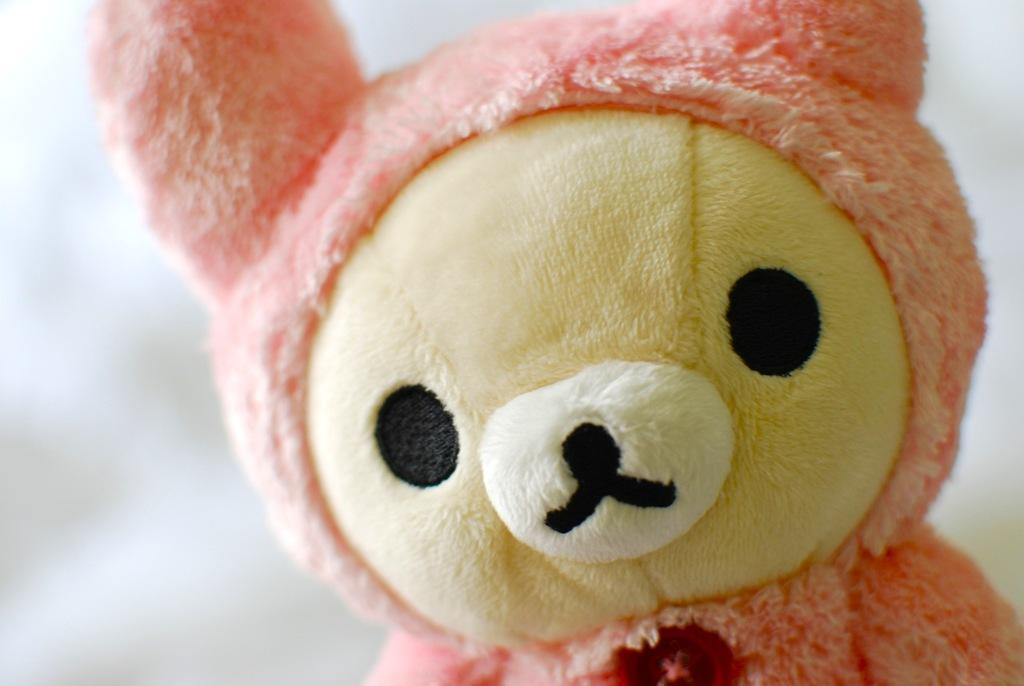What type of object can be seen in the image? There is a soft toy in the image. What color is the background of the image? The background of the image is white. What type of force is being exerted during the battle in the image? There is no battle or force present in the image; it features a soft toy against a white background. 